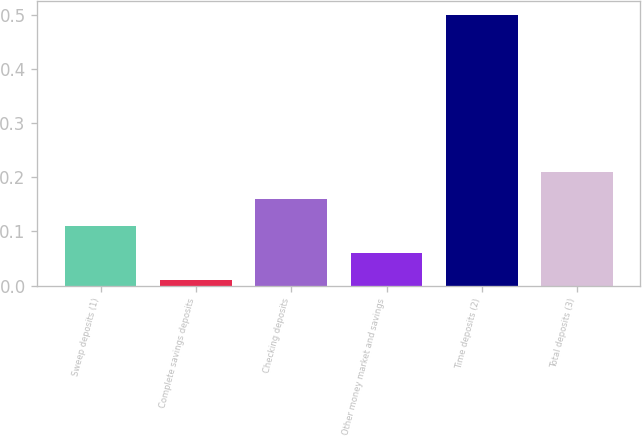<chart> <loc_0><loc_0><loc_500><loc_500><bar_chart><fcel>Sweep deposits (1)<fcel>Complete savings deposits<fcel>Checking deposits<fcel>Other money market and savings<fcel>Time deposits (2)<fcel>Total deposits (3)<nl><fcel>0.11<fcel>0.01<fcel>0.16<fcel>0.06<fcel>0.5<fcel>0.21<nl></chart> 